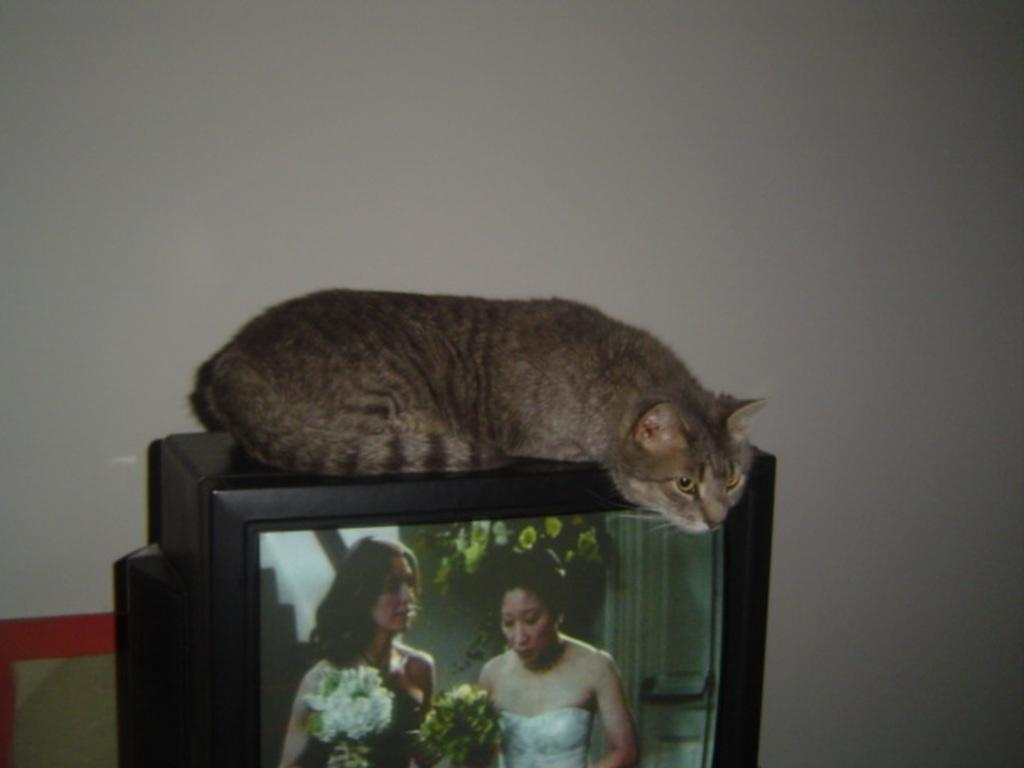What electronic device is present in the image? There is a television in the image. What is lying on top of the television? A cat is lying on the television. How is the cat positioned in relation to the television? The cat is putting its head beside the television. What can be seen in the background of the image? There is a wall in the background of the image. What type of cord is hanging from the pan in the image? There is no pan or cord present in the image. 